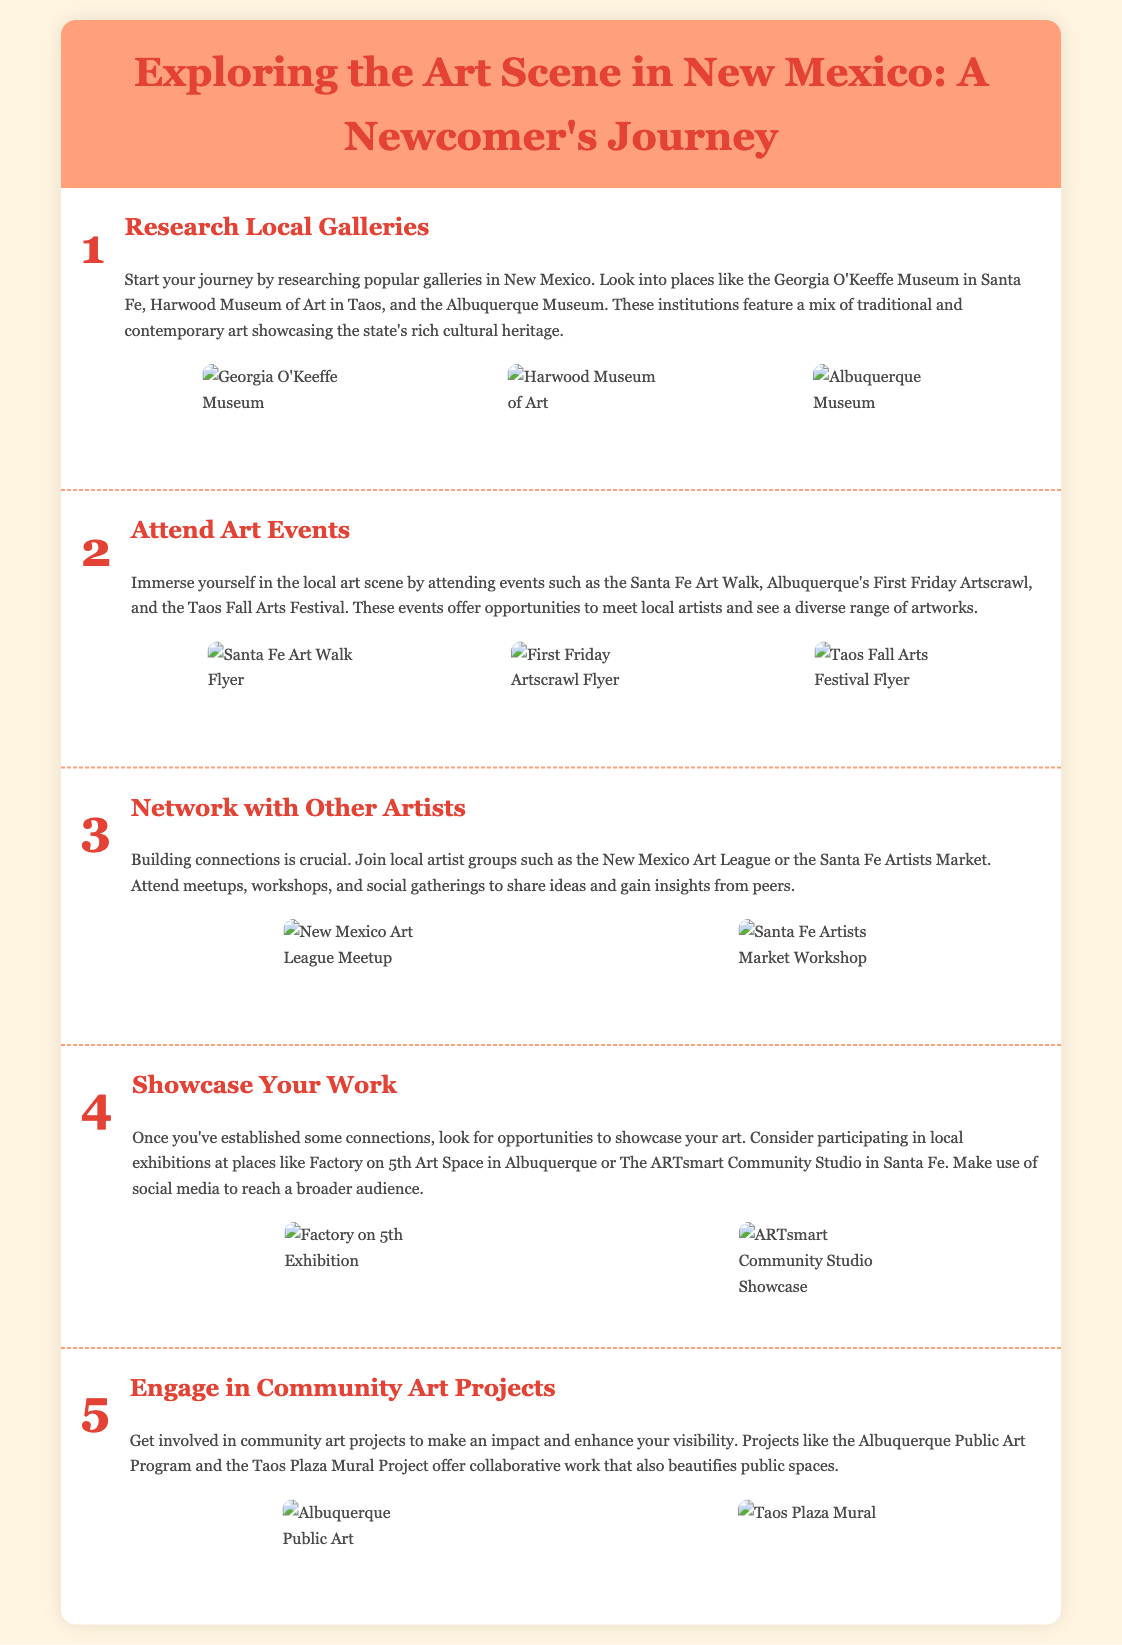What is the first step in exploring the art scene? The first step is to research local galleries in New Mexico.
Answer: Research Local Galleries Which museum is highlighted for its contemporary art? The Albuquerque Museum is mentioned for featuring a mix of traditional and contemporary art.
Answer: Albuquerque Museum What community art project is mentioned? The Taos Plaza Mural Project is one of the projects mentioned for community engagement.
Answer: Taos Plaza Mural Project How many art events are suggested to attend? Three art events are specifically mentioned to immerse in the local art scene.
Answer: Three What is the name of the art league for networking? The networking group suggested is the New Mexico Art League.
Answer: New Mexico Art League Which exhibition space is recommended for showcasing work? The Factory on 5th Art Space in Albuquerque is recommended for showcasing work.
Answer: Factory on 5th Art Space What color highlights the title of the infographic? The title of the infographic is highlighted in the color red (#E34234).
Answer: Red Which festival takes place in Taos? The Taos Fall Arts Festival is specifically mentioned as an event.
Answer: Taos Fall Arts Festival 